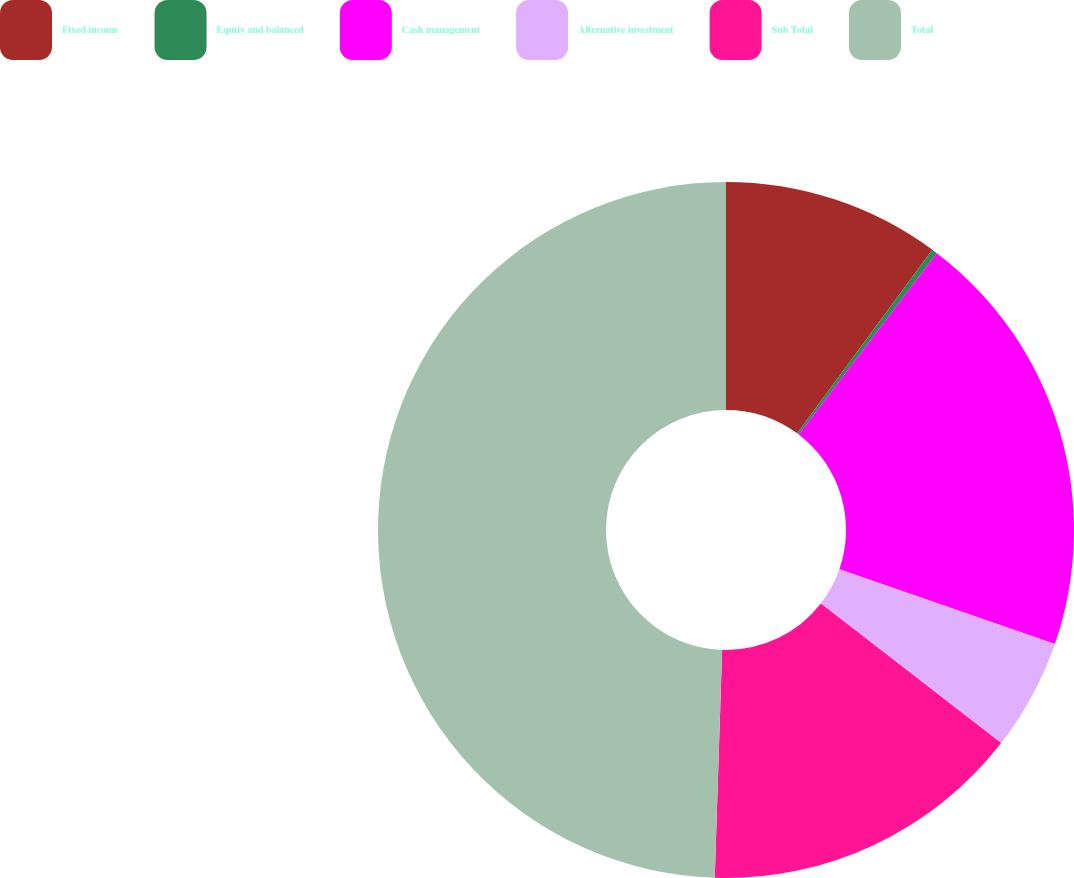Convert chart to OTSL. <chart><loc_0><loc_0><loc_500><loc_500><pie_chart><fcel>Fixed income<fcel>Equity and balanced<fcel>Cash management<fcel>Alternative investment<fcel>Sub Total<fcel>Total<nl><fcel>10.1%<fcel>0.26%<fcel>19.95%<fcel>5.18%<fcel>15.03%<fcel>49.49%<nl></chart> 